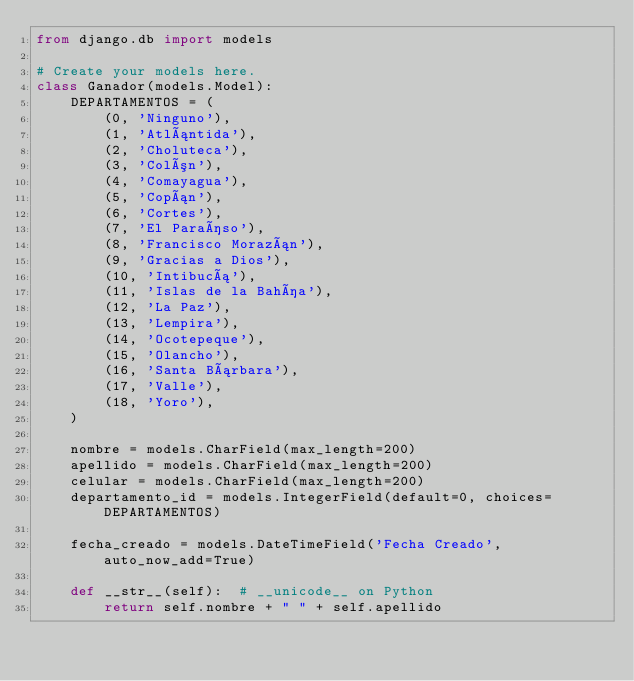Convert code to text. <code><loc_0><loc_0><loc_500><loc_500><_Python_>from django.db import models

# Create your models here.
class Ganador(models.Model):
    DEPARTAMENTOS = (
        (0, 'Ninguno'),
        (1, 'Atlántida'),
        (2, 'Choluteca'),
        (3, 'Colón'),
        (4, 'Comayagua'),
        (5, 'Copán'),
        (6, 'Cortes'),
        (7, 'El Paraíso'),
        (8, 'Francisco Morazán'),
        (9, 'Gracias a Dios'),
        (10, 'Intibucá'),
        (11, 'Islas de la Bahía'),
        (12, 'La Paz'),
        (13, 'Lempira'),
        (14, 'Ocotepeque'),
        (15, 'Olancho'),
        (16, 'Santa Bárbara'),
        (17, 'Valle'),
        (18, 'Yoro'),
    )

    nombre = models.CharField(max_length=200)
    apellido = models.CharField(max_length=200)
    celular = models.CharField(max_length=200)
    departamento_id = models.IntegerField(default=0, choices=DEPARTAMENTOS)

    fecha_creado = models.DateTimeField('Fecha Creado', auto_now_add=True)

    def __str__(self):  # __unicode__ on Python
        return self.nombre + " " + self.apellido</code> 